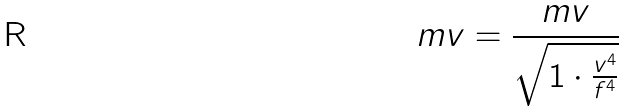Convert formula to latex. <formula><loc_0><loc_0><loc_500><loc_500>m v = \frac { m v } { \sqrt { 1 \cdot \frac { v ^ { 4 } } { f ^ { 4 } } } }</formula> 